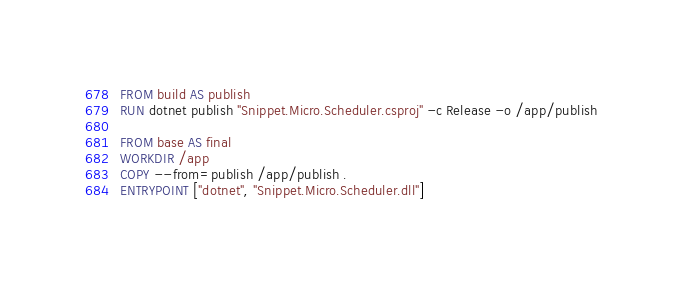Convert code to text. <code><loc_0><loc_0><loc_500><loc_500><_Dockerfile_>
FROM build AS publish
RUN dotnet publish "Snippet.Micro.Scheduler.csproj" -c Release -o /app/publish

FROM base AS final
WORKDIR /app
COPY --from=publish /app/publish .
ENTRYPOINT ["dotnet", "Snippet.Micro.Scheduler.dll"]</code> 